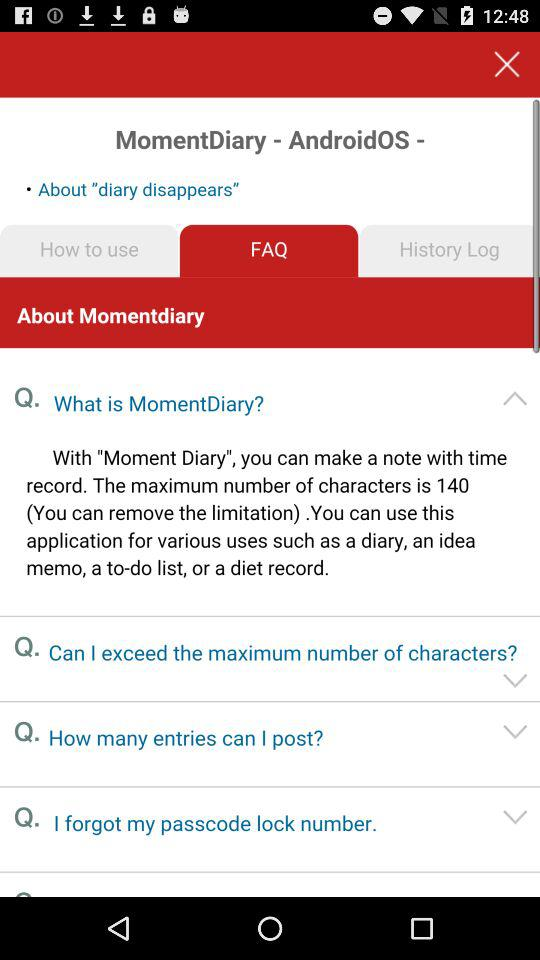What is the maximum number of characters for making a note? The maximum number of characters is 140. 